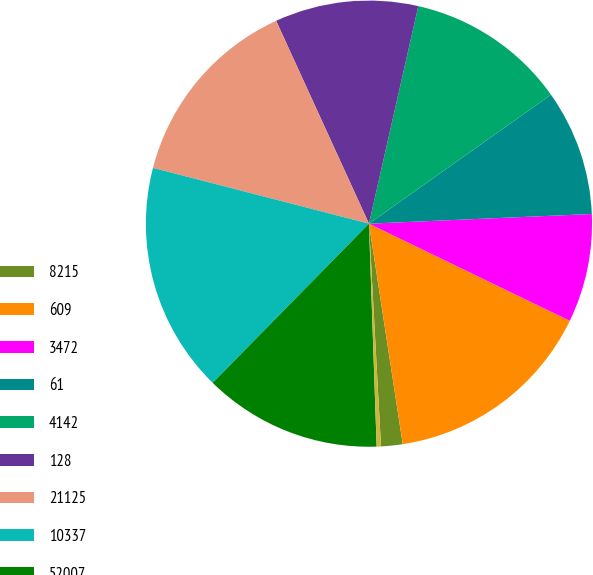Convert chart to OTSL. <chart><loc_0><loc_0><loc_500><loc_500><pie_chart><fcel>8215<fcel>609<fcel>3472<fcel>61<fcel>4142<fcel>128<fcel>21125<fcel>10337<fcel>52007<fcel>23532<nl><fcel>1.56%<fcel>15.41%<fcel>7.86%<fcel>9.12%<fcel>11.64%<fcel>10.38%<fcel>14.15%<fcel>16.67%<fcel>12.9%<fcel>0.31%<nl></chart> 